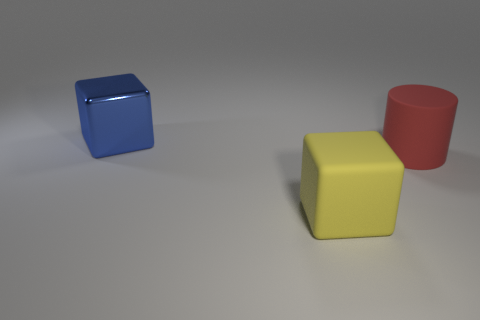Add 3 tiny brown metallic cylinders. How many objects exist? 6 Subtract 1 blocks. How many blocks are left? 1 Subtract all cylinders. How many objects are left? 2 Subtract all cyan cylinders. How many green cubes are left? 0 Add 2 large matte objects. How many large matte objects exist? 4 Subtract all yellow cubes. How many cubes are left? 1 Subtract 0 red cubes. How many objects are left? 3 Subtract all yellow cubes. Subtract all green cylinders. How many cubes are left? 1 Subtract all blue rubber objects. Subtract all large blue cubes. How many objects are left? 2 Add 2 metallic cubes. How many metallic cubes are left? 3 